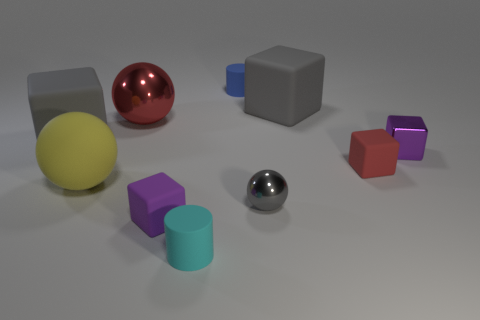There is a rubber thing that is the same color as the shiny block; what is its size?
Ensure brevity in your answer.  Small. What number of small gray objects are left of the big object in front of the purple cube that is to the right of the tiny blue object?
Your answer should be very brief. 0. Is there a big cube of the same color as the tiny shiny sphere?
Your answer should be very brief. Yes. There is another metallic object that is the same size as the gray shiny thing; what color is it?
Your answer should be very brief. Purple. Are there any gray matte objects of the same shape as the tiny gray metal thing?
Offer a terse response. No. The matte thing that is the same color as the metallic block is what shape?
Offer a terse response. Cube. Is there a gray rubber block behind the cylinder behind the big yellow object that is behind the small ball?
Provide a succinct answer. No. What is the shape of the red rubber object that is the same size as the cyan cylinder?
Offer a terse response. Cube. The other object that is the same shape as the blue matte thing is what color?
Your response must be concise. Cyan. What number of objects are either tiny blue rubber cubes or red objects?
Offer a very short reply. 2. 